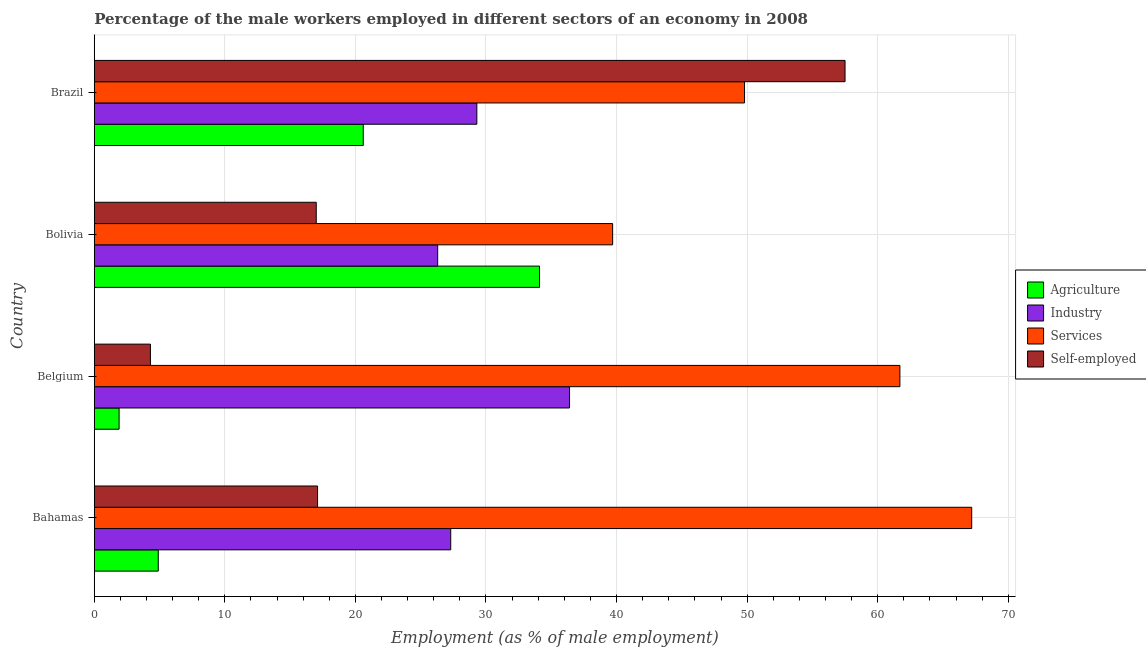How many groups of bars are there?
Your answer should be compact. 4. Are the number of bars per tick equal to the number of legend labels?
Your response must be concise. Yes. Are the number of bars on each tick of the Y-axis equal?
Provide a short and direct response. Yes. How many bars are there on the 4th tick from the top?
Provide a succinct answer. 4. What is the label of the 1st group of bars from the top?
Ensure brevity in your answer.  Brazil. What is the percentage of self employed male workers in Bahamas?
Keep it short and to the point. 17.1. Across all countries, what is the maximum percentage of male workers in services?
Offer a very short reply. 67.2. Across all countries, what is the minimum percentage of male workers in services?
Make the answer very short. 39.7. In which country was the percentage of male workers in agriculture maximum?
Provide a short and direct response. Bolivia. In which country was the percentage of self employed male workers minimum?
Ensure brevity in your answer.  Belgium. What is the total percentage of male workers in services in the graph?
Your answer should be compact. 218.4. What is the difference between the percentage of male workers in services in Belgium and that in Brazil?
Offer a terse response. 11.9. What is the difference between the percentage of self employed male workers in Brazil and the percentage of male workers in services in Bahamas?
Make the answer very short. -9.7. What is the average percentage of male workers in services per country?
Your answer should be compact. 54.6. What is the difference between the percentage of male workers in industry and percentage of male workers in agriculture in Belgium?
Your answer should be compact. 34.5. In how many countries, is the percentage of male workers in agriculture greater than 40 %?
Provide a succinct answer. 0. What is the ratio of the percentage of male workers in services in Belgium to that in Bolivia?
Ensure brevity in your answer.  1.55. What is the difference between the highest and the second highest percentage of male workers in services?
Make the answer very short. 5.5. In how many countries, is the percentage of male workers in agriculture greater than the average percentage of male workers in agriculture taken over all countries?
Offer a very short reply. 2. Is the sum of the percentage of male workers in industry in Belgium and Brazil greater than the maximum percentage of self employed male workers across all countries?
Give a very brief answer. Yes. What does the 1st bar from the top in Brazil represents?
Provide a succinct answer. Self-employed. What does the 2nd bar from the bottom in Bolivia represents?
Offer a very short reply. Industry. Is it the case that in every country, the sum of the percentage of male workers in agriculture and percentage of male workers in industry is greater than the percentage of male workers in services?
Your answer should be very brief. No. Are all the bars in the graph horizontal?
Provide a short and direct response. Yes. Are the values on the major ticks of X-axis written in scientific E-notation?
Your answer should be very brief. No. Where does the legend appear in the graph?
Offer a terse response. Center right. How many legend labels are there?
Provide a succinct answer. 4. How are the legend labels stacked?
Ensure brevity in your answer.  Vertical. What is the title of the graph?
Your answer should be compact. Percentage of the male workers employed in different sectors of an economy in 2008. Does "Taxes on revenue" appear as one of the legend labels in the graph?
Your answer should be compact. No. What is the label or title of the X-axis?
Your answer should be very brief. Employment (as % of male employment). What is the label or title of the Y-axis?
Provide a succinct answer. Country. What is the Employment (as % of male employment) in Agriculture in Bahamas?
Your answer should be compact. 4.9. What is the Employment (as % of male employment) in Industry in Bahamas?
Make the answer very short. 27.3. What is the Employment (as % of male employment) in Services in Bahamas?
Offer a terse response. 67.2. What is the Employment (as % of male employment) in Self-employed in Bahamas?
Give a very brief answer. 17.1. What is the Employment (as % of male employment) in Agriculture in Belgium?
Give a very brief answer. 1.9. What is the Employment (as % of male employment) in Industry in Belgium?
Provide a succinct answer. 36.4. What is the Employment (as % of male employment) of Services in Belgium?
Your answer should be compact. 61.7. What is the Employment (as % of male employment) in Self-employed in Belgium?
Keep it short and to the point. 4.3. What is the Employment (as % of male employment) in Agriculture in Bolivia?
Your response must be concise. 34.1. What is the Employment (as % of male employment) in Industry in Bolivia?
Ensure brevity in your answer.  26.3. What is the Employment (as % of male employment) of Services in Bolivia?
Keep it short and to the point. 39.7. What is the Employment (as % of male employment) of Agriculture in Brazil?
Make the answer very short. 20.6. What is the Employment (as % of male employment) in Industry in Brazil?
Offer a very short reply. 29.3. What is the Employment (as % of male employment) in Services in Brazil?
Provide a succinct answer. 49.8. What is the Employment (as % of male employment) in Self-employed in Brazil?
Your answer should be compact. 57.5. Across all countries, what is the maximum Employment (as % of male employment) of Agriculture?
Your response must be concise. 34.1. Across all countries, what is the maximum Employment (as % of male employment) in Industry?
Ensure brevity in your answer.  36.4. Across all countries, what is the maximum Employment (as % of male employment) of Services?
Your response must be concise. 67.2. Across all countries, what is the maximum Employment (as % of male employment) of Self-employed?
Your answer should be very brief. 57.5. Across all countries, what is the minimum Employment (as % of male employment) in Agriculture?
Provide a succinct answer. 1.9. Across all countries, what is the minimum Employment (as % of male employment) in Industry?
Your answer should be compact. 26.3. Across all countries, what is the minimum Employment (as % of male employment) in Services?
Your answer should be very brief. 39.7. Across all countries, what is the minimum Employment (as % of male employment) in Self-employed?
Give a very brief answer. 4.3. What is the total Employment (as % of male employment) of Agriculture in the graph?
Provide a succinct answer. 61.5. What is the total Employment (as % of male employment) in Industry in the graph?
Your response must be concise. 119.3. What is the total Employment (as % of male employment) in Services in the graph?
Make the answer very short. 218.4. What is the total Employment (as % of male employment) in Self-employed in the graph?
Offer a very short reply. 95.9. What is the difference between the Employment (as % of male employment) in Agriculture in Bahamas and that in Belgium?
Offer a terse response. 3. What is the difference between the Employment (as % of male employment) of Agriculture in Bahamas and that in Bolivia?
Give a very brief answer. -29.2. What is the difference between the Employment (as % of male employment) in Self-employed in Bahamas and that in Bolivia?
Offer a terse response. 0.1. What is the difference between the Employment (as % of male employment) of Agriculture in Bahamas and that in Brazil?
Ensure brevity in your answer.  -15.7. What is the difference between the Employment (as % of male employment) in Self-employed in Bahamas and that in Brazil?
Ensure brevity in your answer.  -40.4. What is the difference between the Employment (as % of male employment) of Agriculture in Belgium and that in Bolivia?
Make the answer very short. -32.2. What is the difference between the Employment (as % of male employment) of Services in Belgium and that in Bolivia?
Ensure brevity in your answer.  22. What is the difference between the Employment (as % of male employment) in Agriculture in Belgium and that in Brazil?
Offer a very short reply. -18.7. What is the difference between the Employment (as % of male employment) of Industry in Belgium and that in Brazil?
Keep it short and to the point. 7.1. What is the difference between the Employment (as % of male employment) of Self-employed in Belgium and that in Brazil?
Keep it short and to the point. -53.2. What is the difference between the Employment (as % of male employment) of Services in Bolivia and that in Brazil?
Keep it short and to the point. -10.1. What is the difference between the Employment (as % of male employment) in Self-employed in Bolivia and that in Brazil?
Give a very brief answer. -40.5. What is the difference between the Employment (as % of male employment) in Agriculture in Bahamas and the Employment (as % of male employment) in Industry in Belgium?
Keep it short and to the point. -31.5. What is the difference between the Employment (as % of male employment) of Agriculture in Bahamas and the Employment (as % of male employment) of Services in Belgium?
Offer a terse response. -56.8. What is the difference between the Employment (as % of male employment) of Agriculture in Bahamas and the Employment (as % of male employment) of Self-employed in Belgium?
Make the answer very short. 0.6. What is the difference between the Employment (as % of male employment) of Industry in Bahamas and the Employment (as % of male employment) of Services in Belgium?
Ensure brevity in your answer.  -34.4. What is the difference between the Employment (as % of male employment) in Services in Bahamas and the Employment (as % of male employment) in Self-employed in Belgium?
Your answer should be very brief. 62.9. What is the difference between the Employment (as % of male employment) of Agriculture in Bahamas and the Employment (as % of male employment) of Industry in Bolivia?
Provide a short and direct response. -21.4. What is the difference between the Employment (as % of male employment) of Agriculture in Bahamas and the Employment (as % of male employment) of Services in Bolivia?
Provide a short and direct response. -34.8. What is the difference between the Employment (as % of male employment) of Services in Bahamas and the Employment (as % of male employment) of Self-employed in Bolivia?
Give a very brief answer. 50.2. What is the difference between the Employment (as % of male employment) of Agriculture in Bahamas and the Employment (as % of male employment) of Industry in Brazil?
Give a very brief answer. -24.4. What is the difference between the Employment (as % of male employment) in Agriculture in Bahamas and the Employment (as % of male employment) in Services in Brazil?
Make the answer very short. -44.9. What is the difference between the Employment (as % of male employment) of Agriculture in Bahamas and the Employment (as % of male employment) of Self-employed in Brazil?
Your answer should be very brief. -52.6. What is the difference between the Employment (as % of male employment) in Industry in Bahamas and the Employment (as % of male employment) in Services in Brazil?
Keep it short and to the point. -22.5. What is the difference between the Employment (as % of male employment) in Industry in Bahamas and the Employment (as % of male employment) in Self-employed in Brazil?
Provide a succinct answer. -30.2. What is the difference between the Employment (as % of male employment) of Agriculture in Belgium and the Employment (as % of male employment) of Industry in Bolivia?
Make the answer very short. -24.4. What is the difference between the Employment (as % of male employment) in Agriculture in Belgium and the Employment (as % of male employment) in Services in Bolivia?
Keep it short and to the point. -37.8. What is the difference between the Employment (as % of male employment) of Agriculture in Belgium and the Employment (as % of male employment) of Self-employed in Bolivia?
Offer a very short reply. -15.1. What is the difference between the Employment (as % of male employment) in Industry in Belgium and the Employment (as % of male employment) in Self-employed in Bolivia?
Keep it short and to the point. 19.4. What is the difference between the Employment (as % of male employment) of Services in Belgium and the Employment (as % of male employment) of Self-employed in Bolivia?
Your answer should be very brief. 44.7. What is the difference between the Employment (as % of male employment) in Agriculture in Belgium and the Employment (as % of male employment) in Industry in Brazil?
Provide a short and direct response. -27.4. What is the difference between the Employment (as % of male employment) of Agriculture in Belgium and the Employment (as % of male employment) of Services in Brazil?
Keep it short and to the point. -47.9. What is the difference between the Employment (as % of male employment) in Agriculture in Belgium and the Employment (as % of male employment) in Self-employed in Brazil?
Provide a short and direct response. -55.6. What is the difference between the Employment (as % of male employment) in Industry in Belgium and the Employment (as % of male employment) in Self-employed in Brazil?
Offer a terse response. -21.1. What is the difference between the Employment (as % of male employment) of Services in Belgium and the Employment (as % of male employment) of Self-employed in Brazil?
Your response must be concise. 4.2. What is the difference between the Employment (as % of male employment) of Agriculture in Bolivia and the Employment (as % of male employment) of Services in Brazil?
Make the answer very short. -15.7. What is the difference between the Employment (as % of male employment) in Agriculture in Bolivia and the Employment (as % of male employment) in Self-employed in Brazil?
Make the answer very short. -23.4. What is the difference between the Employment (as % of male employment) of Industry in Bolivia and the Employment (as % of male employment) of Services in Brazil?
Offer a very short reply. -23.5. What is the difference between the Employment (as % of male employment) in Industry in Bolivia and the Employment (as % of male employment) in Self-employed in Brazil?
Offer a very short reply. -31.2. What is the difference between the Employment (as % of male employment) of Services in Bolivia and the Employment (as % of male employment) of Self-employed in Brazil?
Your answer should be very brief. -17.8. What is the average Employment (as % of male employment) of Agriculture per country?
Keep it short and to the point. 15.38. What is the average Employment (as % of male employment) in Industry per country?
Offer a terse response. 29.82. What is the average Employment (as % of male employment) in Services per country?
Your response must be concise. 54.6. What is the average Employment (as % of male employment) of Self-employed per country?
Provide a short and direct response. 23.98. What is the difference between the Employment (as % of male employment) in Agriculture and Employment (as % of male employment) in Industry in Bahamas?
Your answer should be very brief. -22.4. What is the difference between the Employment (as % of male employment) of Agriculture and Employment (as % of male employment) of Services in Bahamas?
Provide a short and direct response. -62.3. What is the difference between the Employment (as % of male employment) in Industry and Employment (as % of male employment) in Services in Bahamas?
Your answer should be compact. -39.9. What is the difference between the Employment (as % of male employment) of Industry and Employment (as % of male employment) of Self-employed in Bahamas?
Offer a terse response. 10.2. What is the difference between the Employment (as % of male employment) of Services and Employment (as % of male employment) of Self-employed in Bahamas?
Your answer should be compact. 50.1. What is the difference between the Employment (as % of male employment) of Agriculture and Employment (as % of male employment) of Industry in Belgium?
Make the answer very short. -34.5. What is the difference between the Employment (as % of male employment) in Agriculture and Employment (as % of male employment) in Services in Belgium?
Keep it short and to the point. -59.8. What is the difference between the Employment (as % of male employment) of Industry and Employment (as % of male employment) of Services in Belgium?
Your answer should be compact. -25.3. What is the difference between the Employment (as % of male employment) of Industry and Employment (as % of male employment) of Self-employed in Belgium?
Ensure brevity in your answer.  32.1. What is the difference between the Employment (as % of male employment) of Services and Employment (as % of male employment) of Self-employed in Belgium?
Your answer should be very brief. 57.4. What is the difference between the Employment (as % of male employment) of Agriculture and Employment (as % of male employment) of Services in Bolivia?
Your response must be concise. -5.6. What is the difference between the Employment (as % of male employment) of Agriculture and Employment (as % of male employment) of Self-employed in Bolivia?
Keep it short and to the point. 17.1. What is the difference between the Employment (as % of male employment) of Industry and Employment (as % of male employment) of Services in Bolivia?
Provide a short and direct response. -13.4. What is the difference between the Employment (as % of male employment) in Industry and Employment (as % of male employment) in Self-employed in Bolivia?
Keep it short and to the point. 9.3. What is the difference between the Employment (as % of male employment) of Services and Employment (as % of male employment) of Self-employed in Bolivia?
Provide a short and direct response. 22.7. What is the difference between the Employment (as % of male employment) in Agriculture and Employment (as % of male employment) in Services in Brazil?
Give a very brief answer. -29.2. What is the difference between the Employment (as % of male employment) in Agriculture and Employment (as % of male employment) in Self-employed in Brazil?
Offer a terse response. -36.9. What is the difference between the Employment (as % of male employment) of Industry and Employment (as % of male employment) of Services in Brazil?
Offer a terse response. -20.5. What is the difference between the Employment (as % of male employment) in Industry and Employment (as % of male employment) in Self-employed in Brazil?
Ensure brevity in your answer.  -28.2. What is the ratio of the Employment (as % of male employment) of Agriculture in Bahamas to that in Belgium?
Provide a short and direct response. 2.58. What is the ratio of the Employment (as % of male employment) in Services in Bahamas to that in Belgium?
Your answer should be very brief. 1.09. What is the ratio of the Employment (as % of male employment) in Self-employed in Bahamas to that in Belgium?
Offer a very short reply. 3.98. What is the ratio of the Employment (as % of male employment) in Agriculture in Bahamas to that in Bolivia?
Make the answer very short. 0.14. What is the ratio of the Employment (as % of male employment) of Industry in Bahamas to that in Bolivia?
Provide a short and direct response. 1.04. What is the ratio of the Employment (as % of male employment) of Services in Bahamas to that in Bolivia?
Make the answer very short. 1.69. What is the ratio of the Employment (as % of male employment) of Self-employed in Bahamas to that in Bolivia?
Provide a succinct answer. 1.01. What is the ratio of the Employment (as % of male employment) of Agriculture in Bahamas to that in Brazil?
Offer a terse response. 0.24. What is the ratio of the Employment (as % of male employment) in Industry in Bahamas to that in Brazil?
Give a very brief answer. 0.93. What is the ratio of the Employment (as % of male employment) in Services in Bahamas to that in Brazil?
Ensure brevity in your answer.  1.35. What is the ratio of the Employment (as % of male employment) in Self-employed in Bahamas to that in Brazil?
Provide a short and direct response. 0.3. What is the ratio of the Employment (as % of male employment) of Agriculture in Belgium to that in Bolivia?
Your answer should be very brief. 0.06. What is the ratio of the Employment (as % of male employment) of Industry in Belgium to that in Bolivia?
Your response must be concise. 1.38. What is the ratio of the Employment (as % of male employment) of Services in Belgium to that in Bolivia?
Offer a very short reply. 1.55. What is the ratio of the Employment (as % of male employment) in Self-employed in Belgium to that in Bolivia?
Make the answer very short. 0.25. What is the ratio of the Employment (as % of male employment) of Agriculture in Belgium to that in Brazil?
Provide a short and direct response. 0.09. What is the ratio of the Employment (as % of male employment) in Industry in Belgium to that in Brazil?
Your answer should be compact. 1.24. What is the ratio of the Employment (as % of male employment) in Services in Belgium to that in Brazil?
Provide a succinct answer. 1.24. What is the ratio of the Employment (as % of male employment) in Self-employed in Belgium to that in Brazil?
Make the answer very short. 0.07. What is the ratio of the Employment (as % of male employment) in Agriculture in Bolivia to that in Brazil?
Your answer should be very brief. 1.66. What is the ratio of the Employment (as % of male employment) of Industry in Bolivia to that in Brazil?
Offer a very short reply. 0.9. What is the ratio of the Employment (as % of male employment) of Services in Bolivia to that in Brazil?
Offer a very short reply. 0.8. What is the ratio of the Employment (as % of male employment) of Self-employed in Bolivia to that in Brazil?
Offer a very short reply. 0.3. What is the difference between the highest and the second highest Employment (as % of male employment) in Agriculture?
Provide a succinct answer. 13.5. What is the difference between the highest and the second highest Employment (as % of male employment) in Industry?
Provide a short and direct response. 7.1. What is the difference between the highest and the second highest Employment (as % of male employment) in Self-employed?
Give a very brief answer. 40.4. What is the difference between the highest and the lowest Employment (as % of male employment) in Agriculture?
Offer a very short reply. 32.2. What is the difference between the highest and the lowest Employment (as % of male employment) in Industry?
Provide a succinct answer. 10.1. What is the difference between the highest and the lowest Employment (as % of male employment) of Services?
Provide a succinct answer. 27.5. What is the difference between the highest and the lowest Employment (as % of male employment) of Self-employed?
Give a very brief answer. 53.2. 